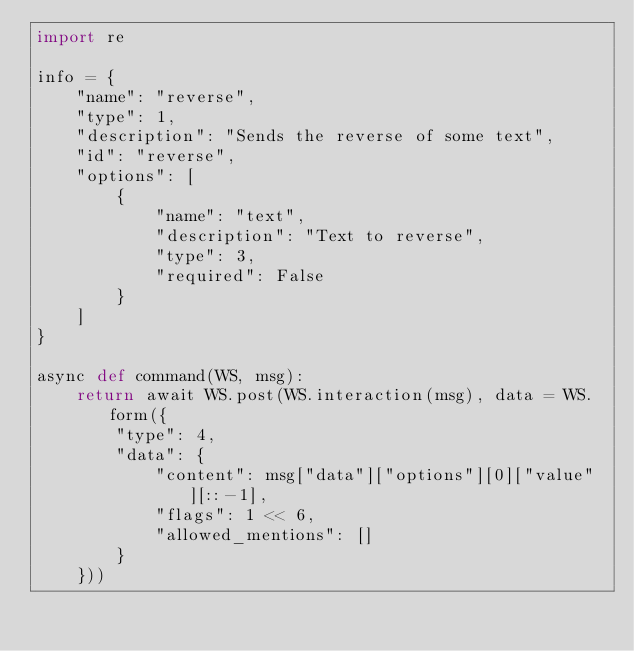<code> <loc_0><loc_0><loc_500><loc_500><_Python_>import re

info = {
    "name": "reverse",
    "type": 1,
    "description": "Sends the reverse of some text",
    "id": "reverse",
    "options": [
        {
            "name": "text",
            "description": "Text to reverse",
            "type": 3,
            "required": False
        }
    ]
}

async def command(WS, msg):
    return await WS.post(WS.interaction(msg), data = WS.form({
        "type": 4,
        "data": {
            "content": msg["data"]["options"][0]["value"][::-1],
            "flags": 1 << 6,
            "allowed_mentions": []
        }
    }))
</code> 